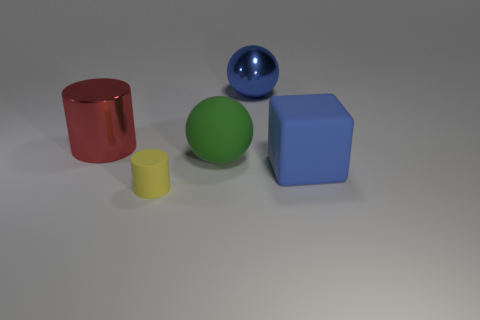There is a big object that is the same color as the metal ball; what is its material?
Provide a succinct answer. Rubber. There is a shiny thing that is the same color as the cube; what size is it?
Provide a succinct answer. Large. Is there anything else that has the same color as the big metallic sphere?
Ensure brevity in your answer.  Yes. What number of red metal balls are there?
Make the answer very short. 0. What material is the large thing to the left of the sphere in front of the big metal ball made of?
Give a very brief answer. Metal. What color is the object behind the metal thing left of the large metallic object that is to the right of the small yellow rubber cylinder?
Your response must be concise. Blue. Is the color of the metallic sphere the same as the tiny rubber cylinder?
Your answer should be compact. No. What number of brown metal cubes are the same size as the matte cube?
Your response must be concise. 0. Is the number of large things left of the big red shiny cylinder greater than the number of blue matte objects in front of the large cube?
Keep it short and to the point. No. What color is the large metallic thing in front of the sphere that is on the right side of the green thing?
Provide a short and direct response. Red. 